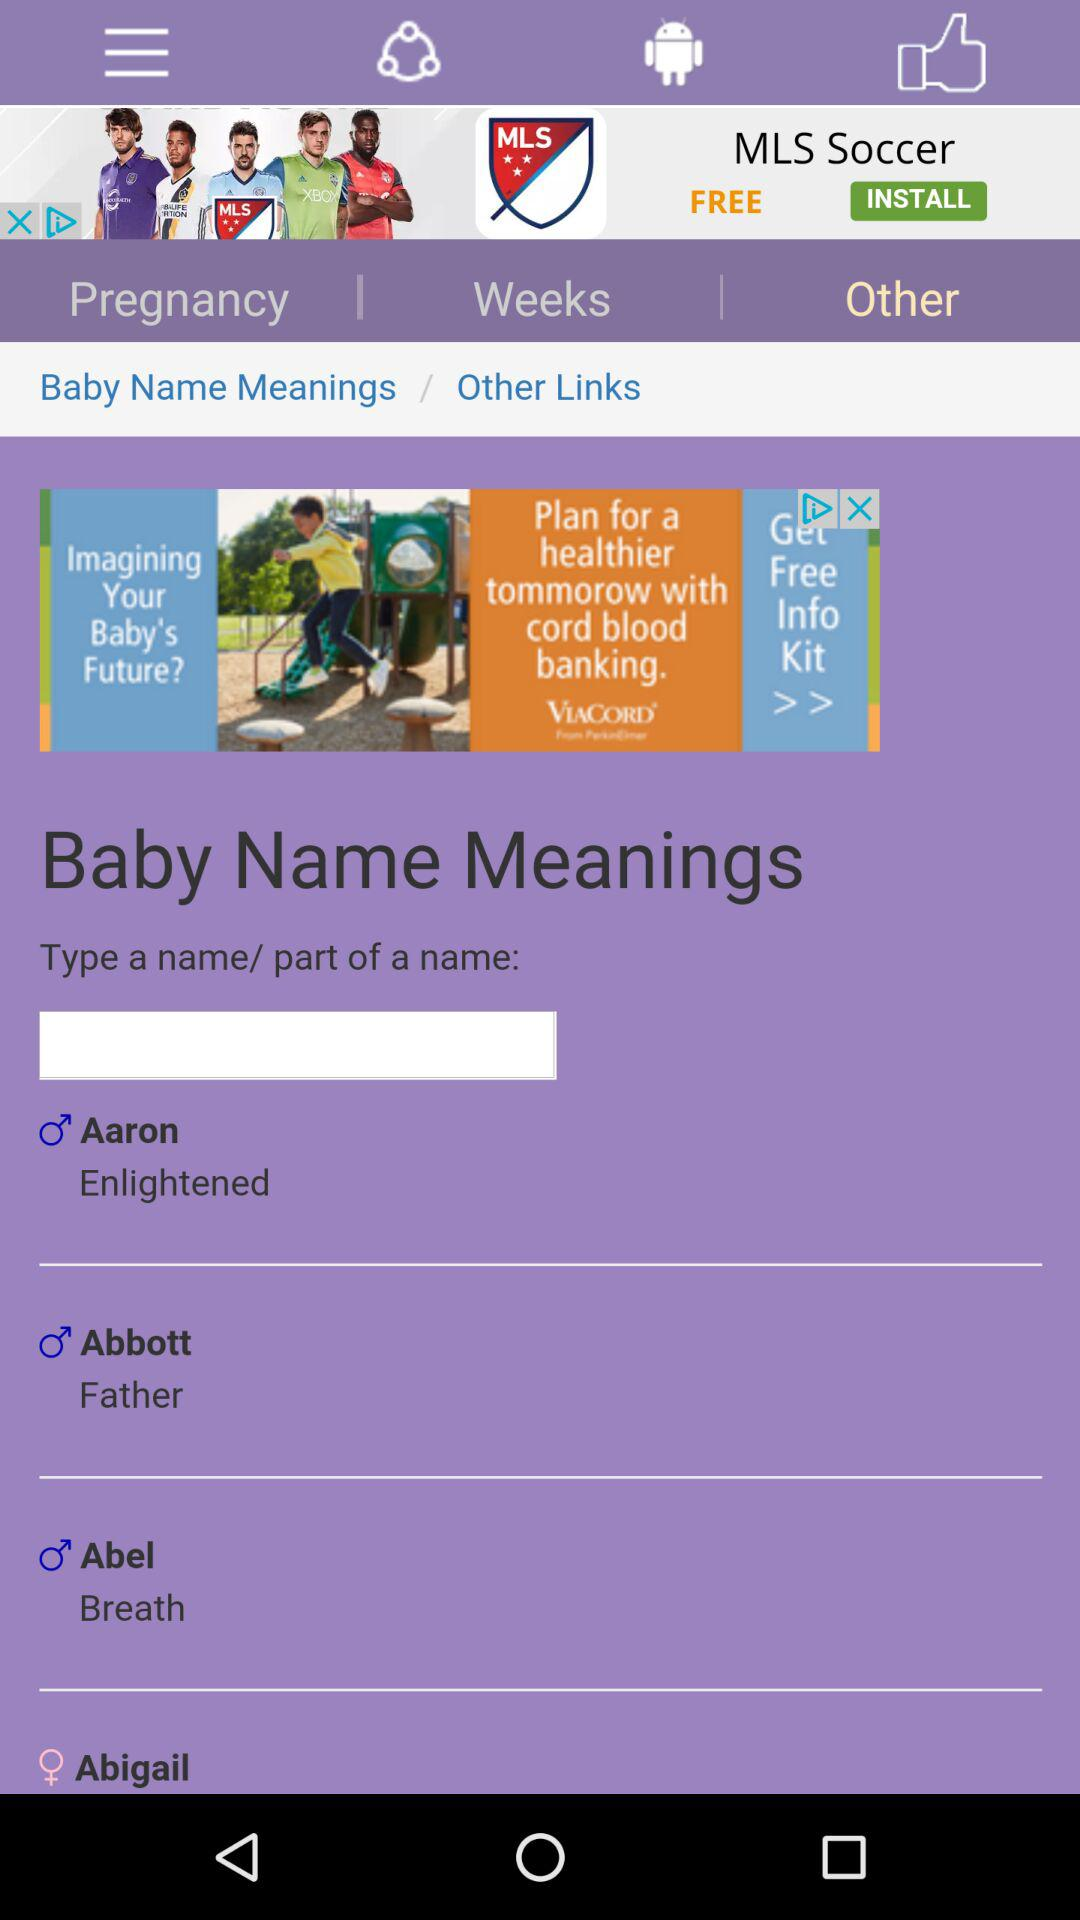Which option is selected? The selected option is "Other". 